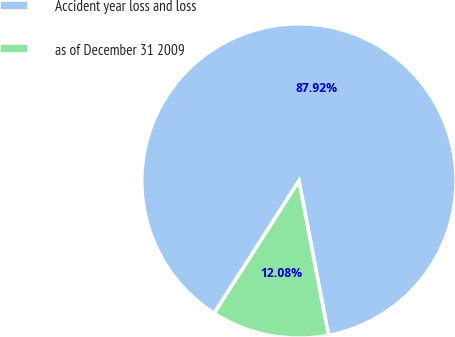Convert chart. <chart><loc_0><loc_0><loc_500><loc_500><pie_chart><fcel>Accident year loss and loss<fcel>as of December 31 2009<nl><fcel>87.92%<fcel>12.08%<nl></chart> 